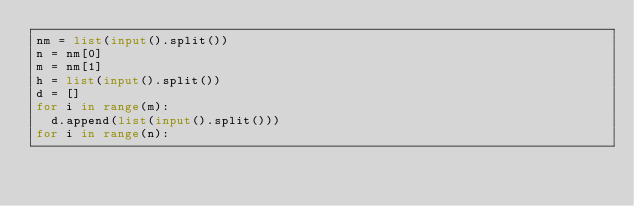Convert code to text. <code><loc_0><loc_0><loc_500><loc_500><_Python_>nm = list(input().split())
n = nm[0]
m = nm[1]
h = list(input().split())
d = []
for i in range(m):
  d.append(list(input().split()))
for i in range(n):
  
  </code> 